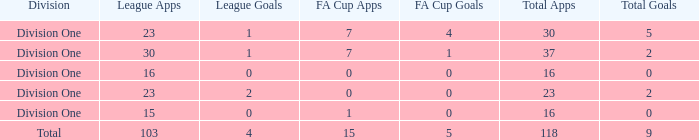The total goals have a FA Cup Apps larger than 1, and a Total Apps of 37, and a League Apps smaller than 30?, what is the total number? 0.0. 